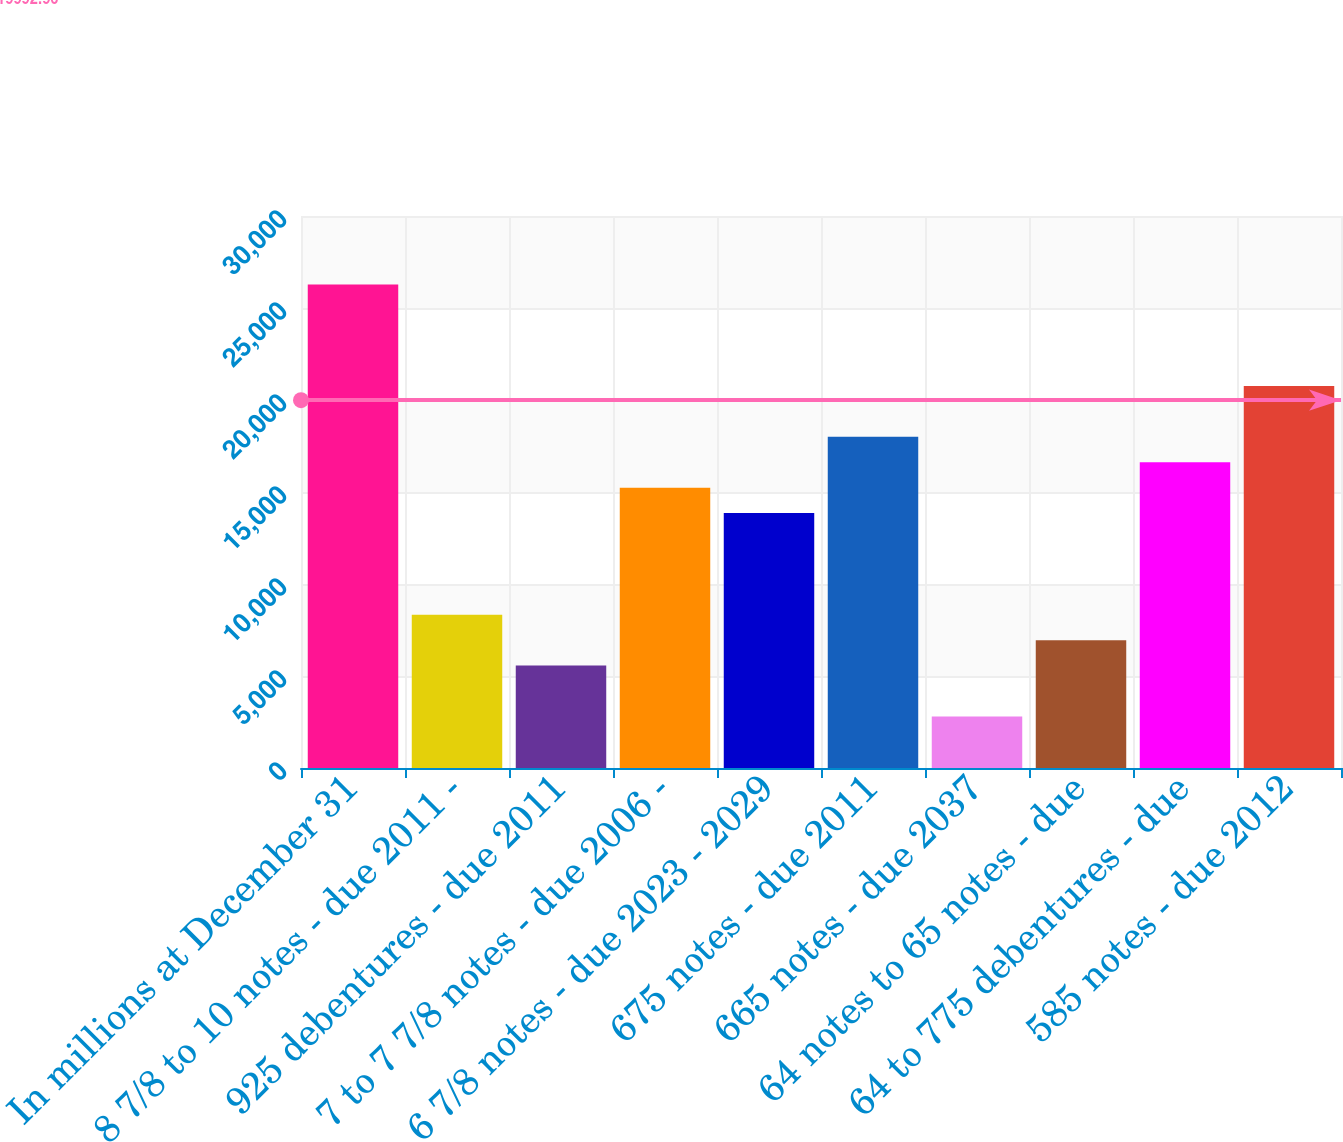Convert chart to OTSL. <chart><loc_0><loc_0><loc_500><loc_500><bar_chart><fcel>In millions at December 31<fcel>8 7/8 to 10 notes - due 2011 -<fcel>925 debentures - due 2011<fcel>7 to 7 7/8 notes - due 2006 -<fcel>6 7/8 notes - due 2023 - 2029<fcel>675 notes - due 2011<fcel>665 notes - due 2037<fcel>64 notes to 65 notes - due<fcel>64 to 775 debentures - due<fcel>585 notes - due 2012<nl><fcel>26283.9<fcel>8329.6<fcel>5567.4<fcel>15235.1<fcel>13854<fcel>17997.3<fcel>2805.2<fcel>6948.5<fcel>16616.2<fcel>20759.5<nl></chart> 